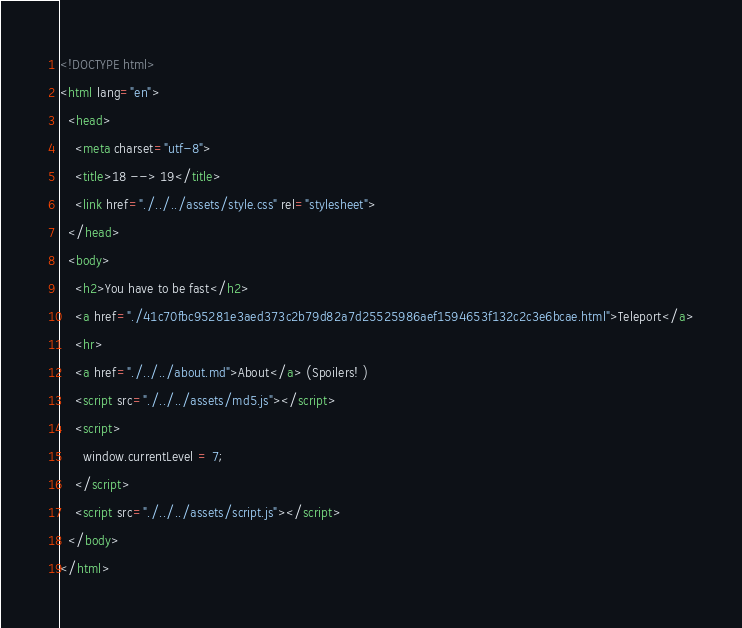Convert code to text. <code><loc_0><loc_0><loc_500><loc_500><_HTML_><!DOCTYPE html>
<html lang="en">
  <head>
    <meta charset="utf-8">
    <title>18 --> 19</title>
    <link href="./../../assets/style.css" rel="stylesheet">
  </head>
  <body>
    <h2>You have to be fast</h2>
    <a href="./41c70fbc95281e3aed373c2b79d82a7d25525986aef1594653f132c2c3e6bcae.html">Teleport</a>
    <hr>
    <a href="./../../about.md">About</a> (Spoilers! )
    <script src="./../../assets/md5.js"></script>
    <script>
      window.currentLevel = 7;
    </script>
    <script src="./../../assets/script.js"></script>
  </body>
</html></code> 